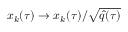Convert formula to latex. <formula><loc_0><loc_0><loc_500><loc_500>x _ { k } ( \tau ) \rightarrow x _ { k } ( \tau ) / \sqrt { \hat { q } ( \tau ) }</formula> 